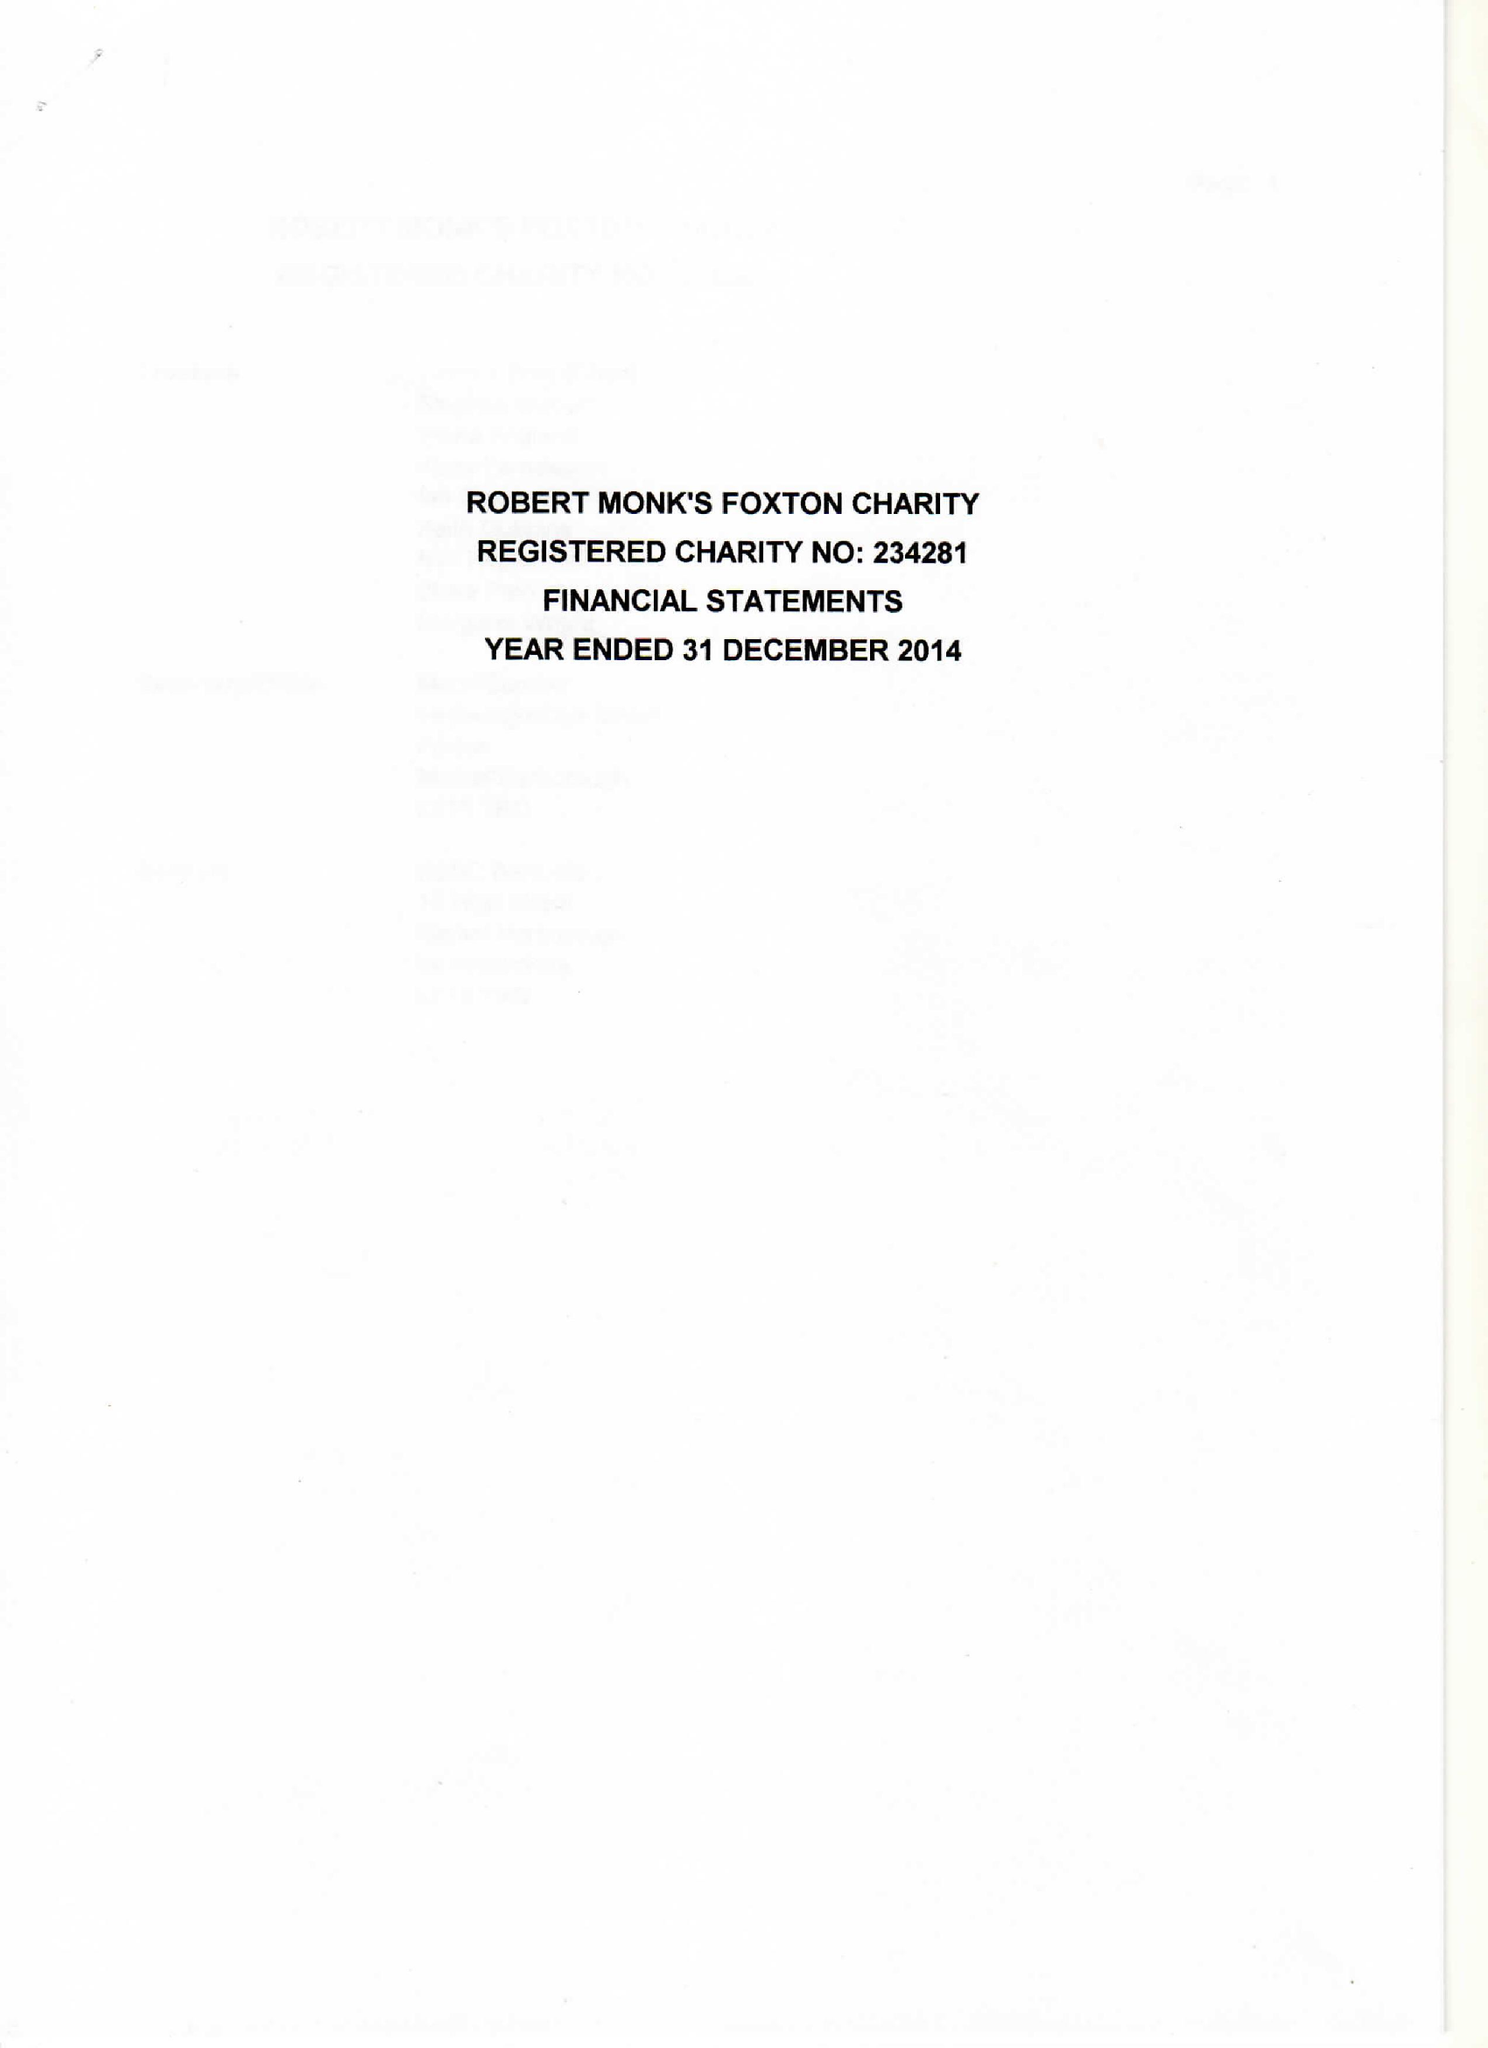What is the value for the charity_name?
Answer the question using a single word or phrase. Robert Monks Foxton Charity 